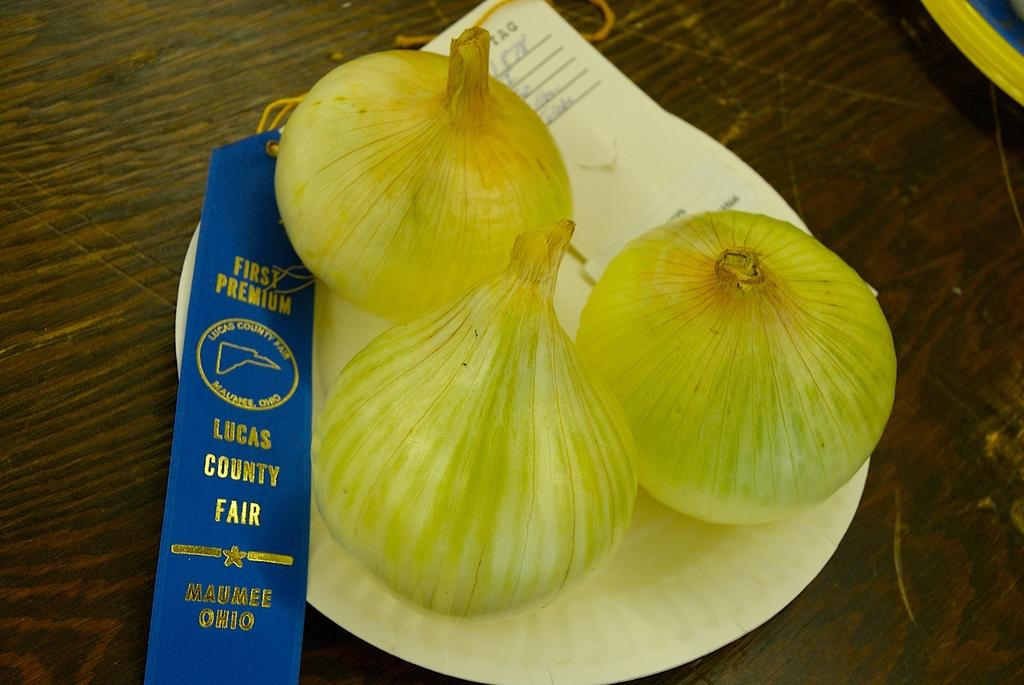What is on the plate in the image? There are onions on a plate in the image. What else is on the plate besides the onions? There is paper on the plate. Where is the plate located in the image? The plate is placed on a table. How does the glue on the plate attempt to wave at the onions in the image? There is no glue present on the plate, and onions do not require waving at them. 